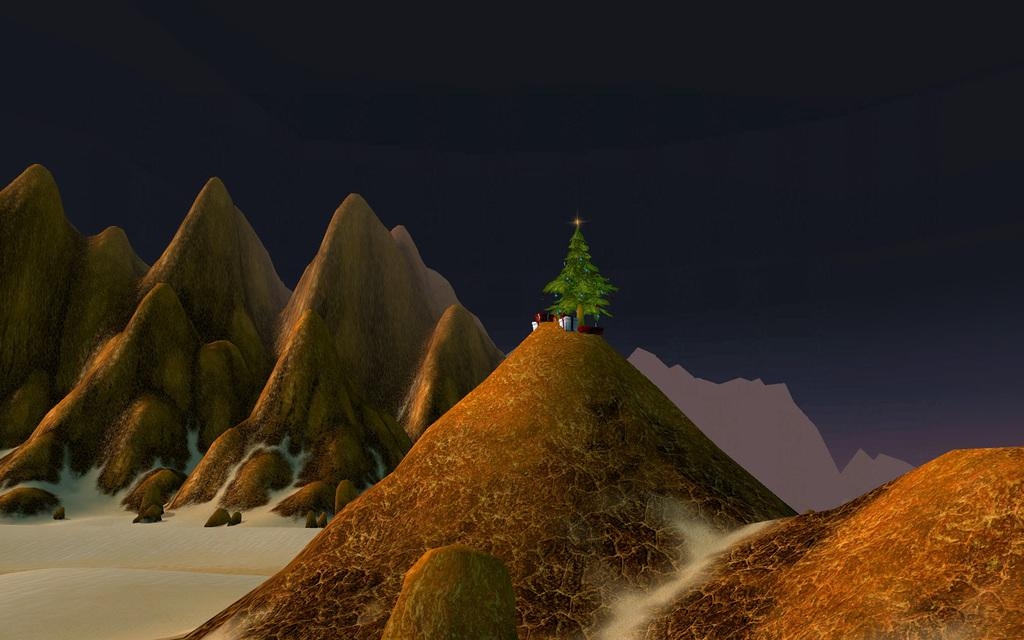What type of image is being described? The image is an animated picture. What type of landscape can be seen in the image? There are mountains in the image. What is present on the ground in the image? There are stones on the ground in the image. What seasonal decoration is featured in the image? There is a Christmas tree in the image. What else can be seen in the image besides the mountains, stones, and Christmas tree? There are various objects in the image. What is visible in the background of the image? The sky is visible in the image. Can you tell me what the judge is saying to the slave in the image? There is no judge or slave present in the image; it features an animated scene with mountains, stones, a Christmas tree, and various objects. 